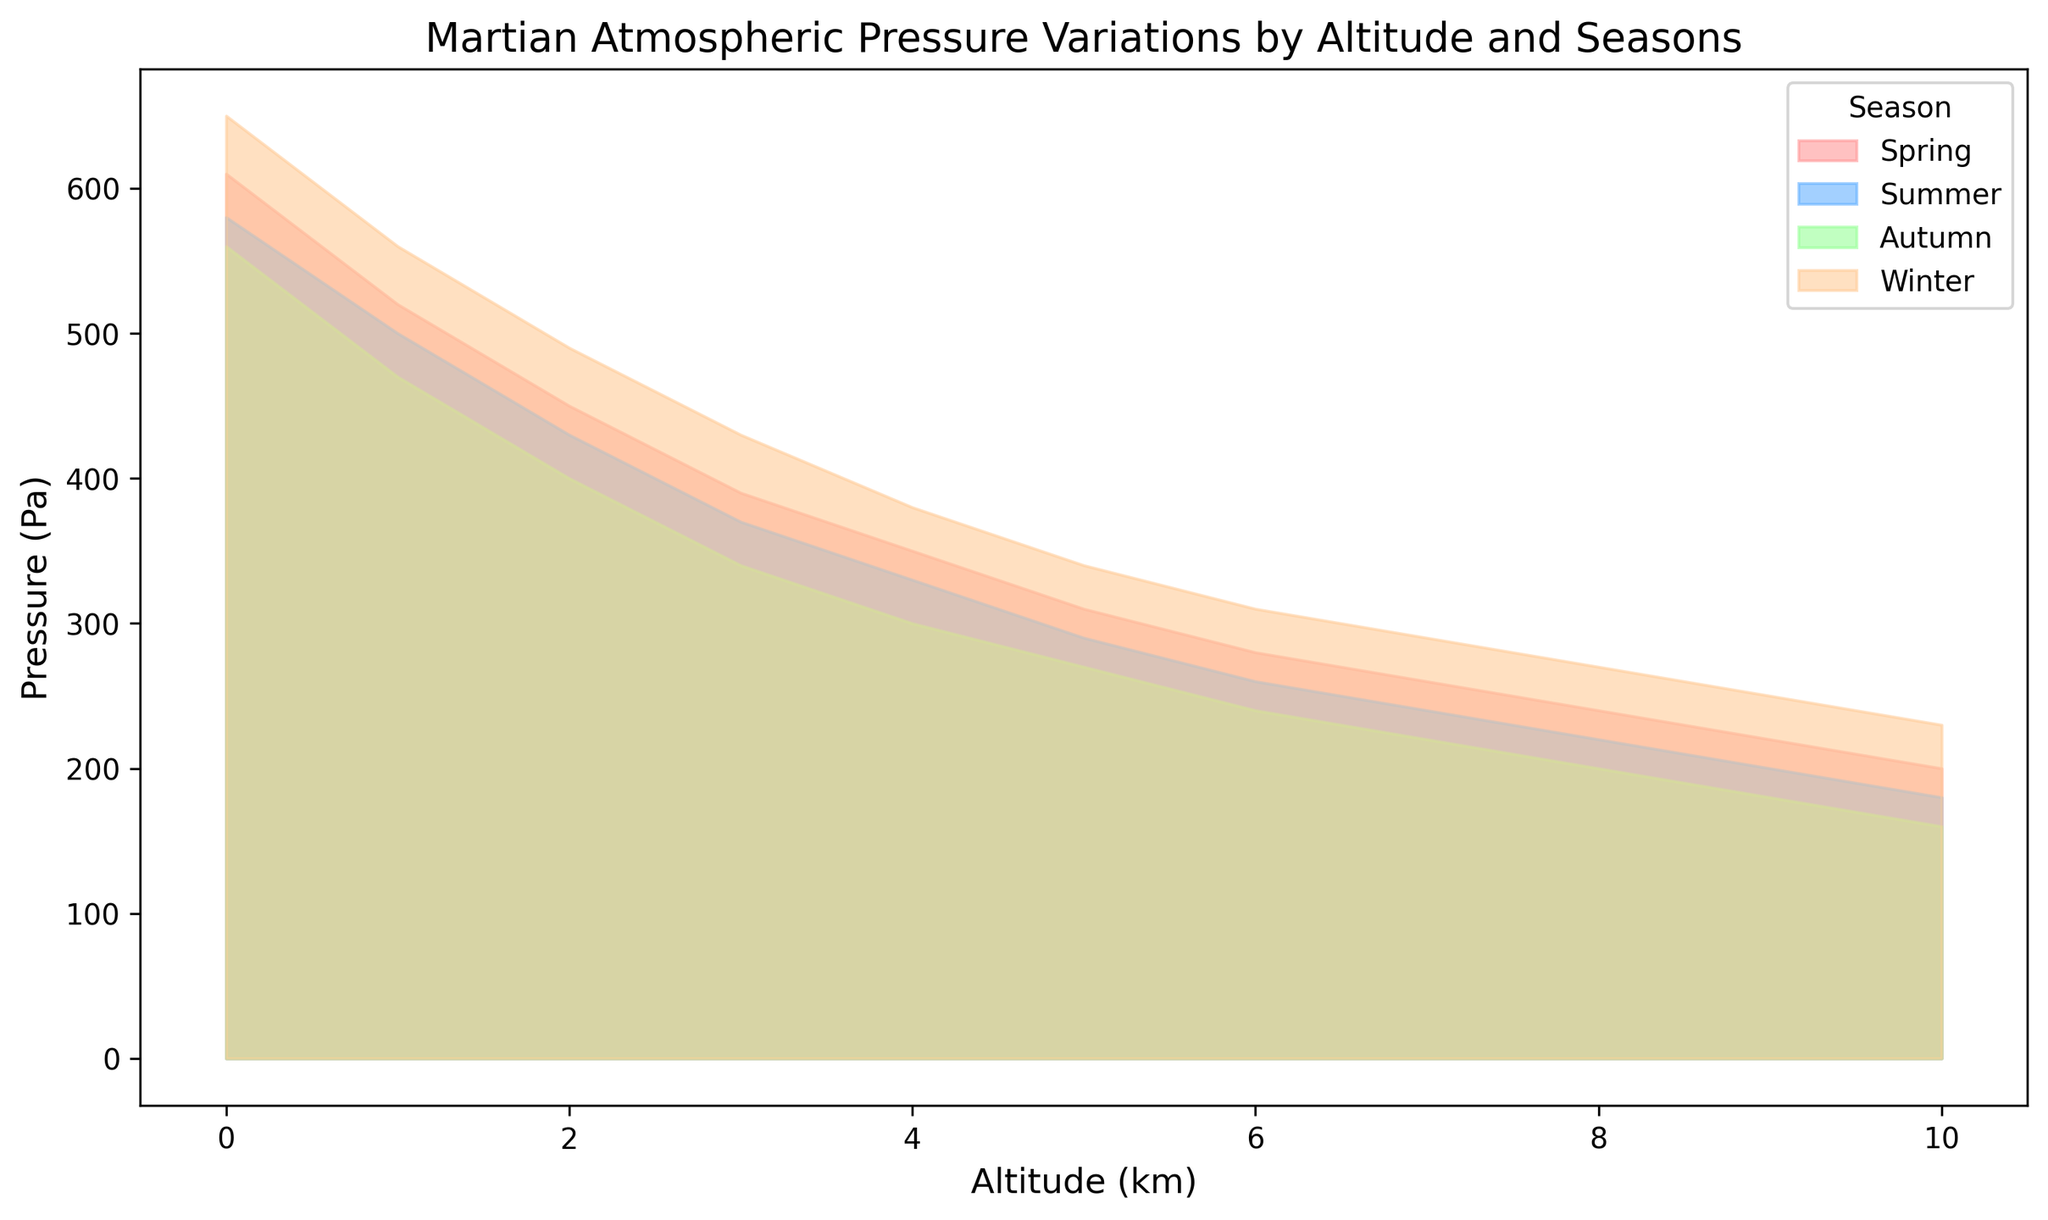What altitude shows the highest pressure in Winter? To find this answer, locate the winter area in the chart (orange color) and identify the highest point on the y-axis (pressure) among the altitudes.
Answer: 0 km What is the difference in pressure between altitude 0 km in Spring and altitude 10 km in Spring? Look at the spring area (pink color) and check the pressure values for 0 km and 10 km. Spring pressure at 0 km is 610 Pa and at 10 km is 200 Pa. Calculate the difference: 610 - 200 = 410
Answer: 410 Pa Which season shows the lowest pressure at 7 km altitude? For 7 km altitude, compare the pressure values among the seasons. The pressures are Spring: 260 Pa, Summer: 240 Pa, Autumn: 220 Pa, and Winter: 290 Pa. The lowest value is in Autumn.
Answer: Autumn How does the pressure change with altitude in Summer? Observe the summer area (blue color). As altitude increases from 0 km to 10 km, the pressure decreases from 580 Pa to 180 Pa.
Answer: Decreases Is there any altitude where all seasons exhibit equal pressure? Scan across all altitudes in the chart to see if there is an altitude where all the seasons' areas intersect at the same pressure. There is no such intersection point on the chart.
Answer: No At which altitude does Spring have the same pressure as Autumn at 3 km altitude? Find the pressure for Autumn at 3 km altitude, which is 340 Pa. Then, find where Spring intersects this pressure value. At 5 km altitude, Spring has 340 Pa.
Answer: 5 km What is the average pressure for Winter at altitudes 2 km and 8 km? Find Winter's pressure at 2 km (490 Pa) and 8 km (270 Pa). Calculate the average: (490 + 270) / 2 = 760 / 2 = 380 Pa
Answer: 380 Pa Which season has the steepest decline in pressure from 0 km to 10 km? Compare the decline in pressure across all seasons: 
- Spring: 610-200 = 410 Pa
- Summer: 580-180 = 400 Pa
- Autumn: 560-160 = 400 Pa
- Winter: 650-230 = 420 Pa
The steepest decline is in Winter.
Answer: Winter 